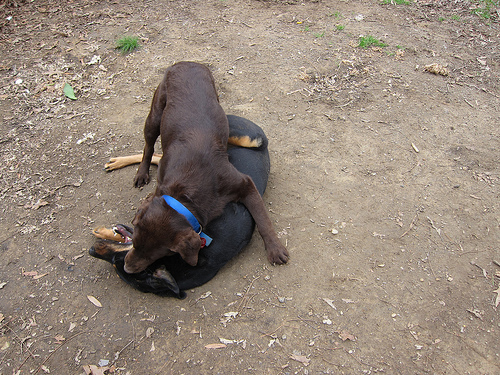<image>
Can you confirm if the black dog is on the brown dog? No. The black dog is not positioned on the brown dog. They may be near each other, but the black dog is not supported by or resting on top of the brown dog. 